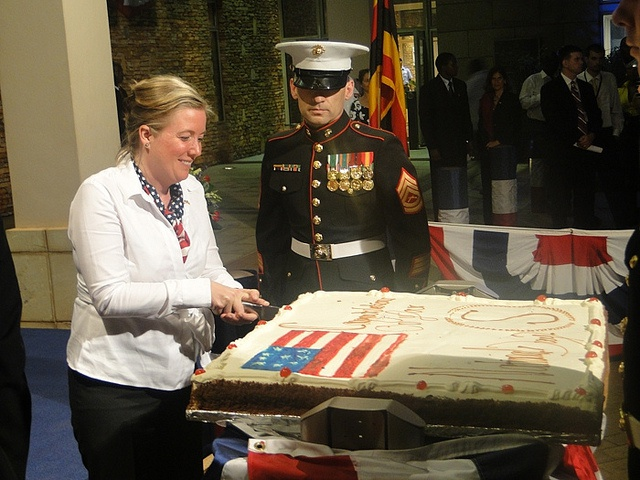Describe the objects in this image and their specific colors. I can see people in olive, white, black, darkgray, and gray tones, cake in olive, beige, black, and tan tones, people in olive, black, gray, and maroon tones, people in olive, black, and gray tones, and people in olive, black, and gray tones in this image. 